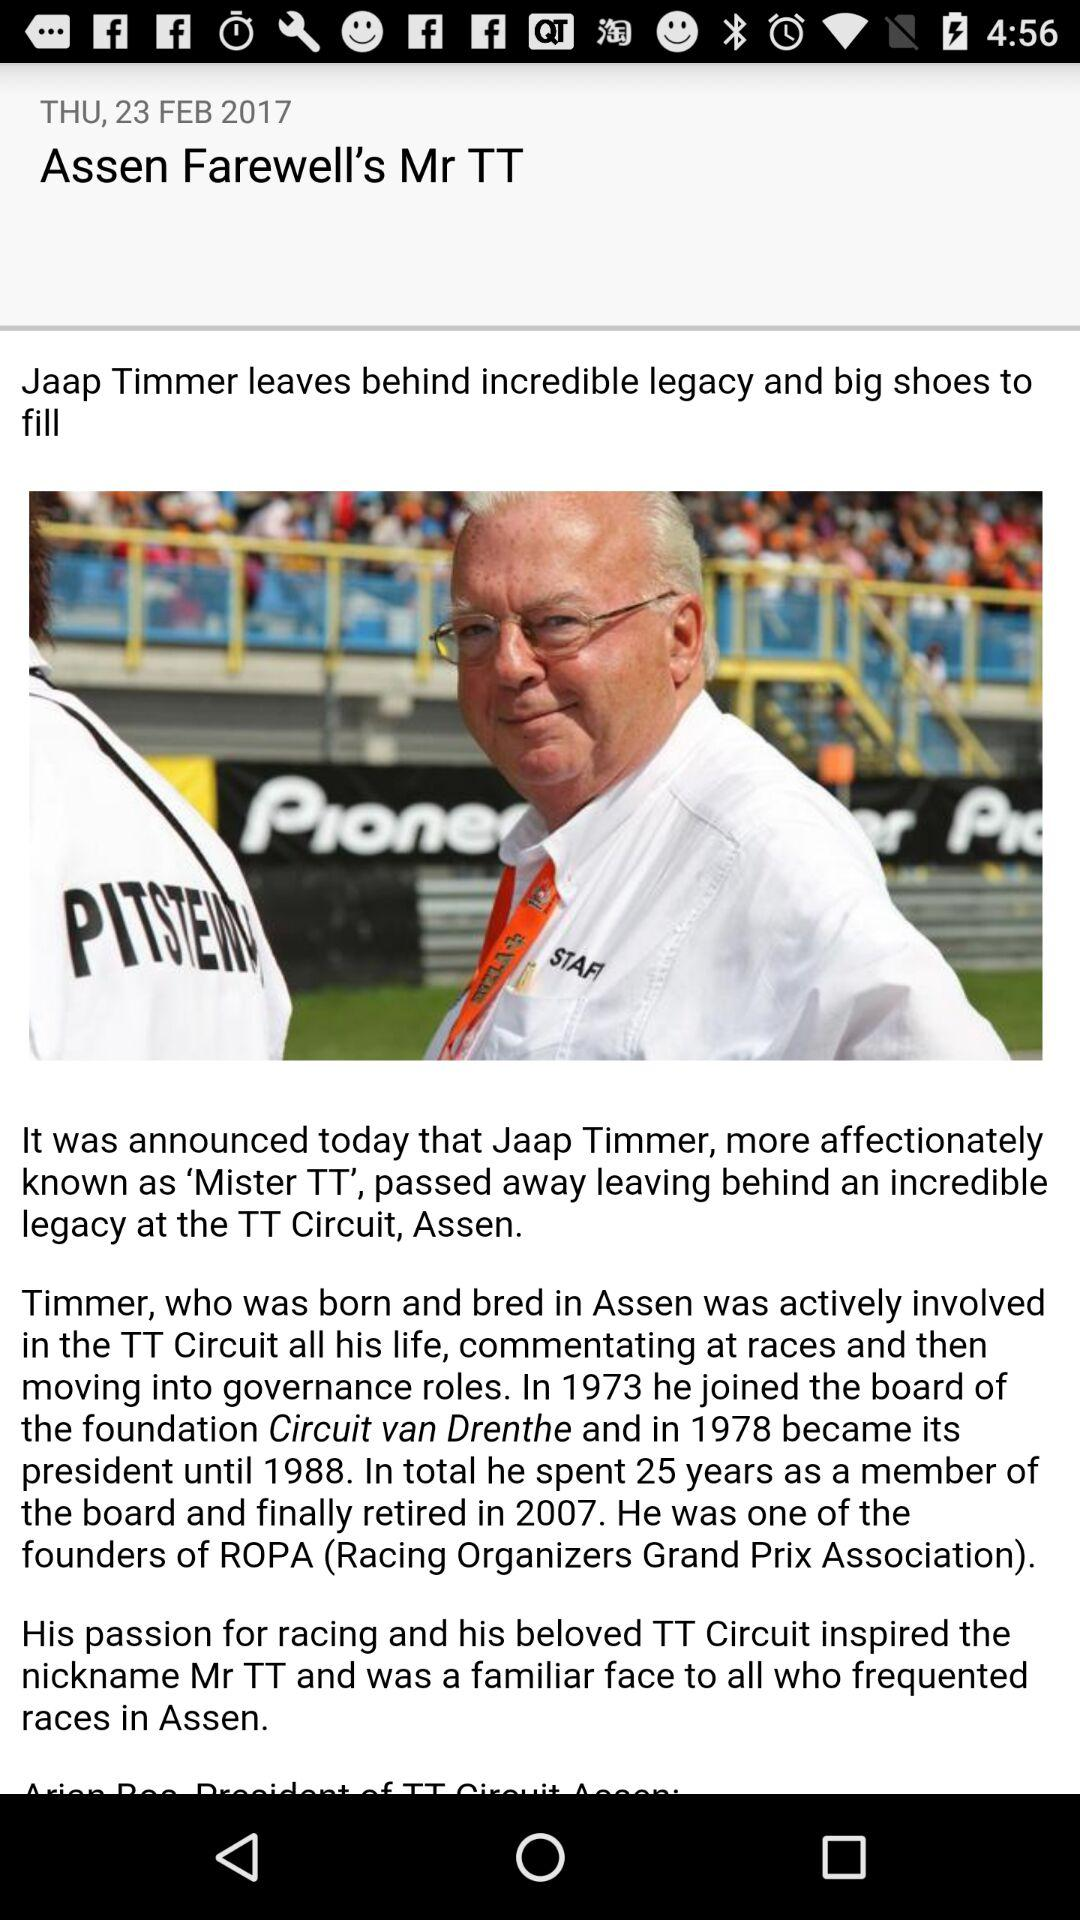How much time did Jaap Timmer spend as a member of the board? Jaap Timmer spent 25 years as a member of the board. 